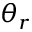<formula> <loc_0><loc_0><loc_500><loc_500>\theta _ { r }</formula> 